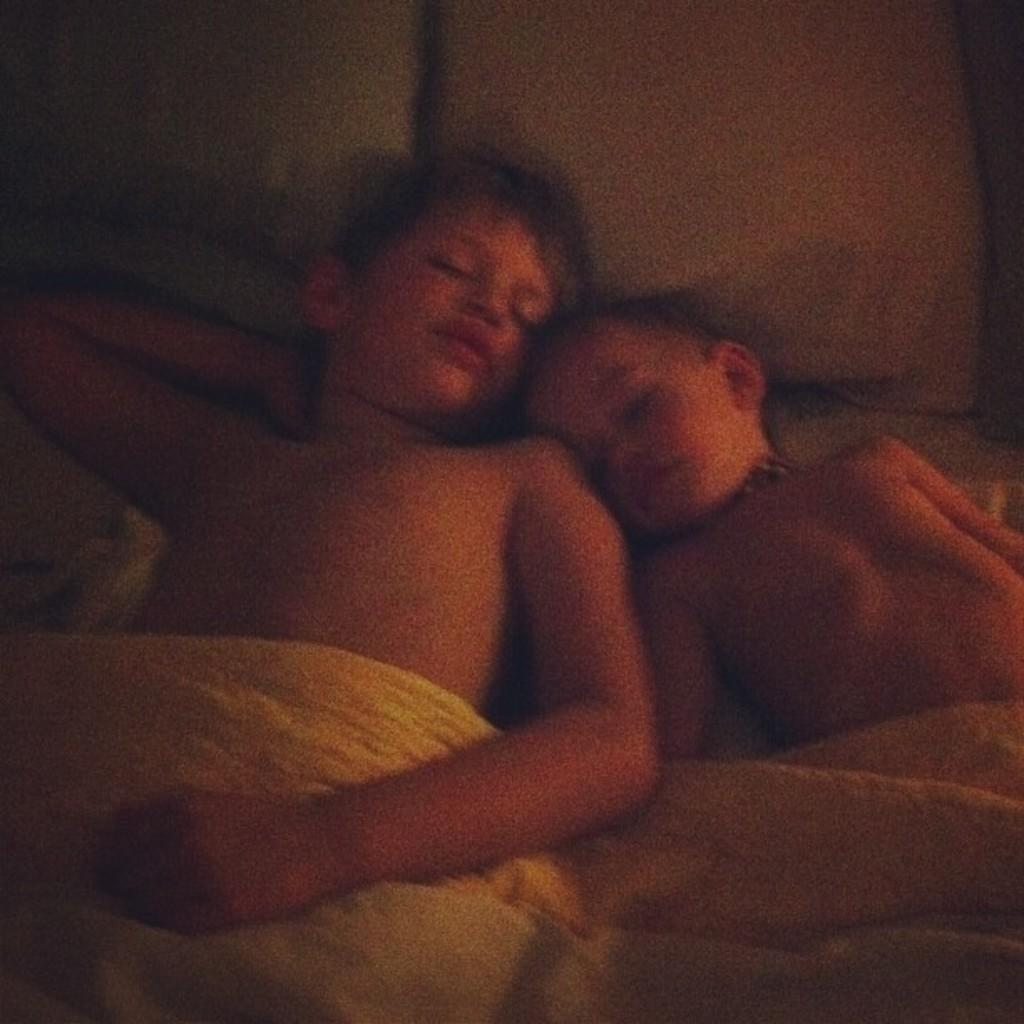How many kids are present in the image? There are two kids in the image. What are the kids doing in the image? The kids are sleeping on a bed. What is covering the kids while they sleep? There is a blanket on top of the kids. What might be used for head support while sleeping in the image? There are pillows in the image. What type of government is depicted in the image? There is no depiction of a government in the image; it features two kids sleeping on a bed with a blanket and pillows. 